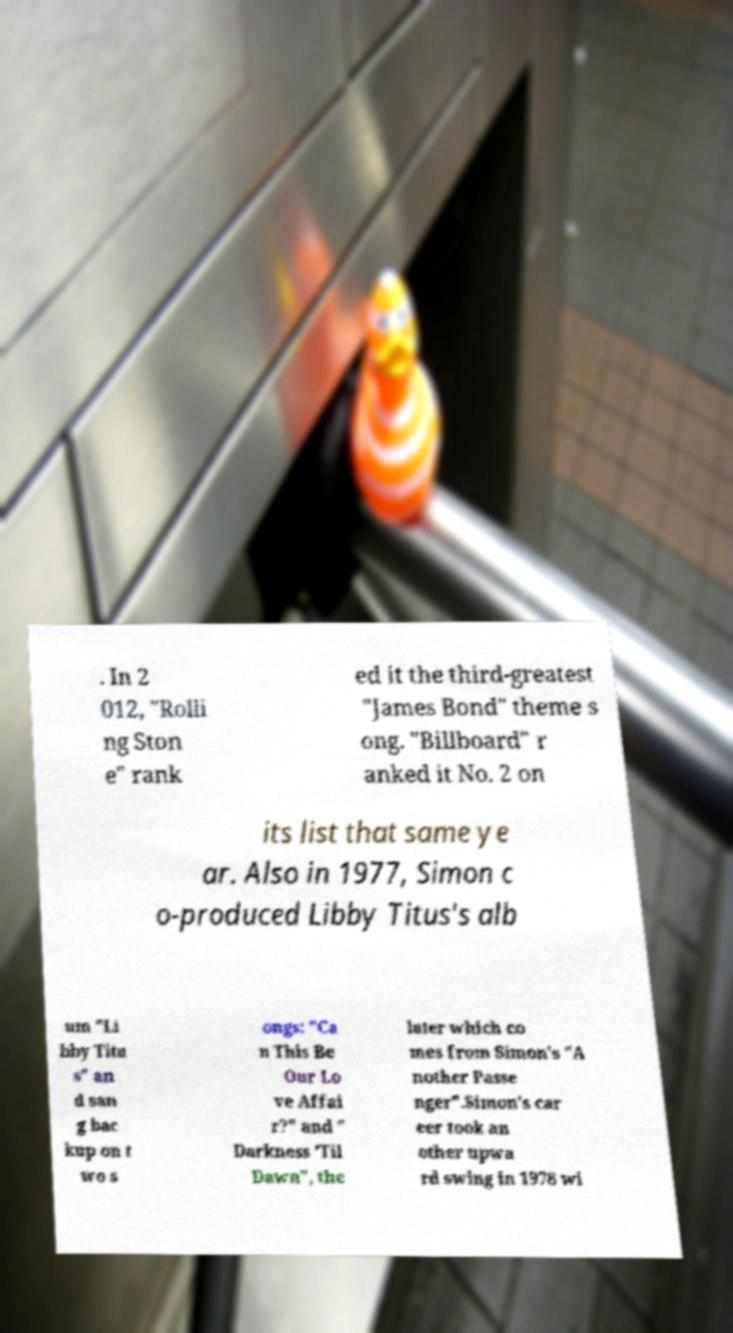Please identify and transcribe the text found in this image. . In 2 012, "Rolli ng Ston e" rank ed it the third-greatest "James Bond" theme s ong. "Billboard" r anked it No. 2 on its list that same ye ar. Also in 1977, Simon c o-produced Libby Titus's alb um "Li bby Titu s" an d san g bac kup on t wo s ongs: "Ca n This Be Our Lo ve Affai r?" and " Darkness 'Til Dawn", the later which co mes from Simon's "A nother Passe nger".Simon's car eer took an other upwa rd swing in 1978 wi 